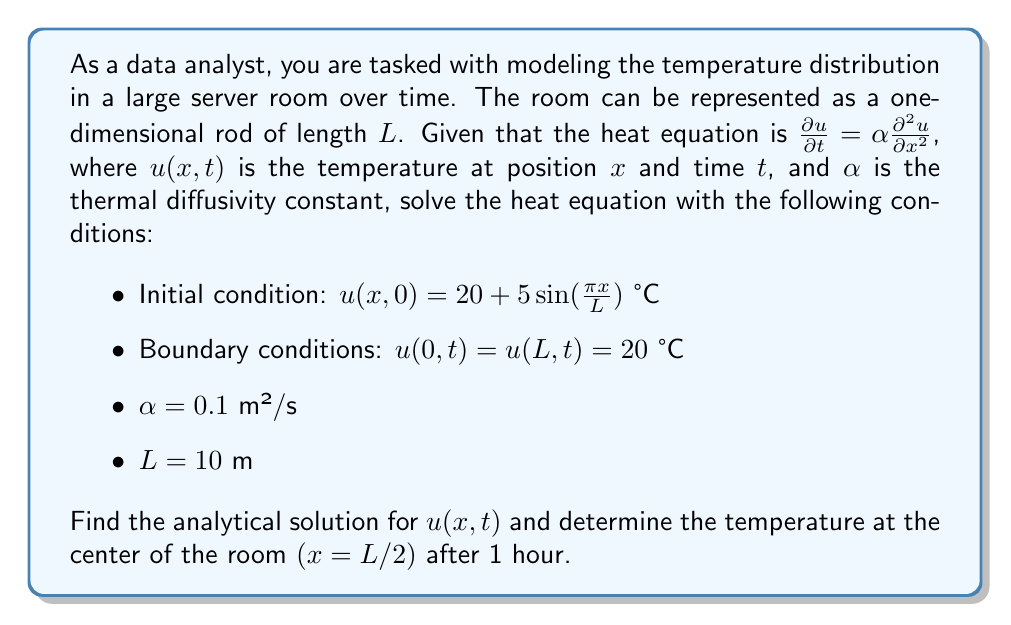Teach me how to tackle this problem. To solve this heat equation problem, we'll follow these steps:

1) The general solution to the heat equation with the given boundary conditions is of the form:

   $$u(x,t) = 20 + \sum_{n=1}^{\infty} B_n \sin(\frac{n\pi x}{L})e^{-\alpha(\frac{n\pi}{L})^2t}$$

2) To find $B_n$, we need to match the initial condition:

   $$20 + 5\sin(\frac{\pi x}{L}) = 20 + \sum_{n=1}^{\infty} B_n \sin(\frac{n\pi x}{L})$$

3) By comparing coefficients, we can see that $B_1 = 5$ and $B_n = 0$ for $n > 1$.

4) Therefore, our solution becomes:

   $$u(x,t) = 20 + 5\sin(\frac{\pi x}{L})e^{-\alpha(\frac{\pi}{L})^2t}$$

5) Now, let's substitute the given values:
   - $\alpha = 0.1$ m²/s
   - $L = 10$ m
   - $t = 1$ hour = 3600 seconds
   - $x = L/2 = 5$ m (center of the room)

6) Plugging these into our solution:

   $$u(5,3600) = 20 + 5\sin(\frac{\pi \cdot 5}{10})e^{-0.1(\frac{\pi}{10})^2 \cdot 3600}$$

7) Simplify:
   $$u(5,3600) = 20 + 5\sin(\frac{\pi}{2})e^{-0.1(\frac{\pi^2}{100}) \cdot 3600}$$
   $$= 20 + 5 \cdot 1 \cdot e^{-11.3097}$$
   $$= 20 + 5 \cdot (1.22 \times 10^{-5})$$
   $$= 20.0000061$$

8) Rounding to 4 decimal places: 20.0000 °C
Answer: The temperature at the center of the room after 1 hour is 20.0000 °C (rounded to 4 decimal places). 